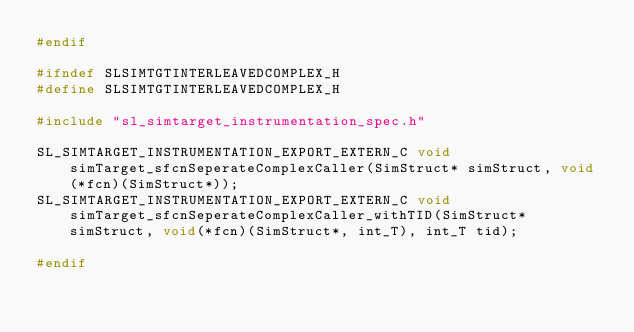Convert code to text. <code><loc_0><loc_0><loc_500><loc_500><_C_>#endif

#ifndef SLSIMTGTINTERLEAVEDCOMPLEX_H
#define SLSIMTGTINTERLEAVEDCOMPLEX_H

#include "sl_simtarget_instrumentation_spec.h"

SL_SIMTARGET_INSTRUMENTATION_EXPORT_EXTERN_C void simTarget_sfcnSeperateComplexCaller(SimStruct* simStruct, void(*fcn)(SimStruct*));
SL_SIMTARGET_INSTRUMENTATION_EXPORT_EXTERN_C void simTarget_sfcnSeperateComplexCaller_withTID(SimStruct* simStruct, void(*fcn)(SimStruct*, int_T), int_T tid);

#endif
</code> 